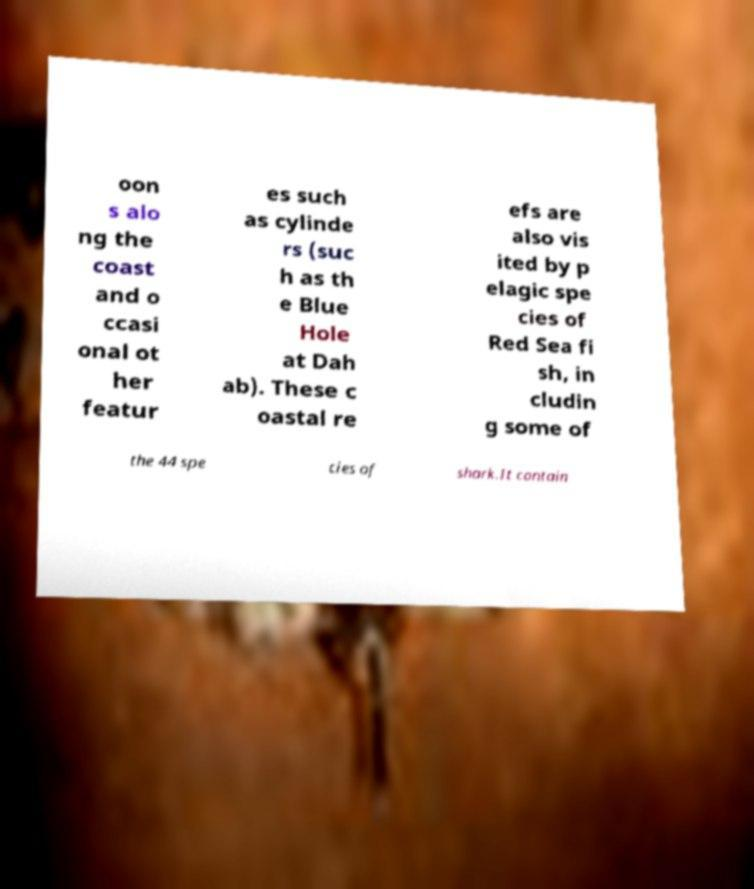I need the written content from this picture converted into text. Can you do that? oon s alo ng the coast and o ccasi onal ot her featur es such as cylinde rs (suc h as th e Blue Hole at Dah ab). These c oastal re efs are also vis ited by p elagic spe cies of Red Sea fi sh, in cludin g some of the 44 spe cies of shark.It contain 